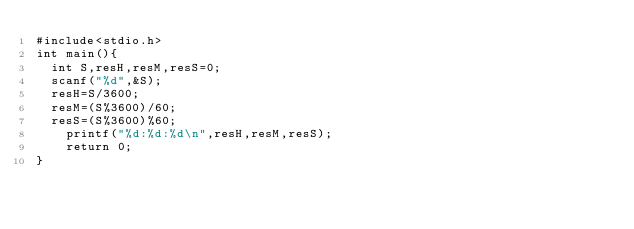<code> <loc_0><loc_0><loc_500><loc_500><_C_>#include<stdio.h>
int main(){
  int S,resH,resM,resS=0;
  scanf("%d",&S);
  resH=S/3600;
  resM=(S%3600)/60;
  resS=(S%3600)%60;
    printf("%d:%d:%d\n",resH,resM,resS);
    return 0;
}</code> 